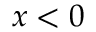Convert formula to latex. <formula><loc_0><loc_0><loc_500><loc_500>x < 0</formula> 